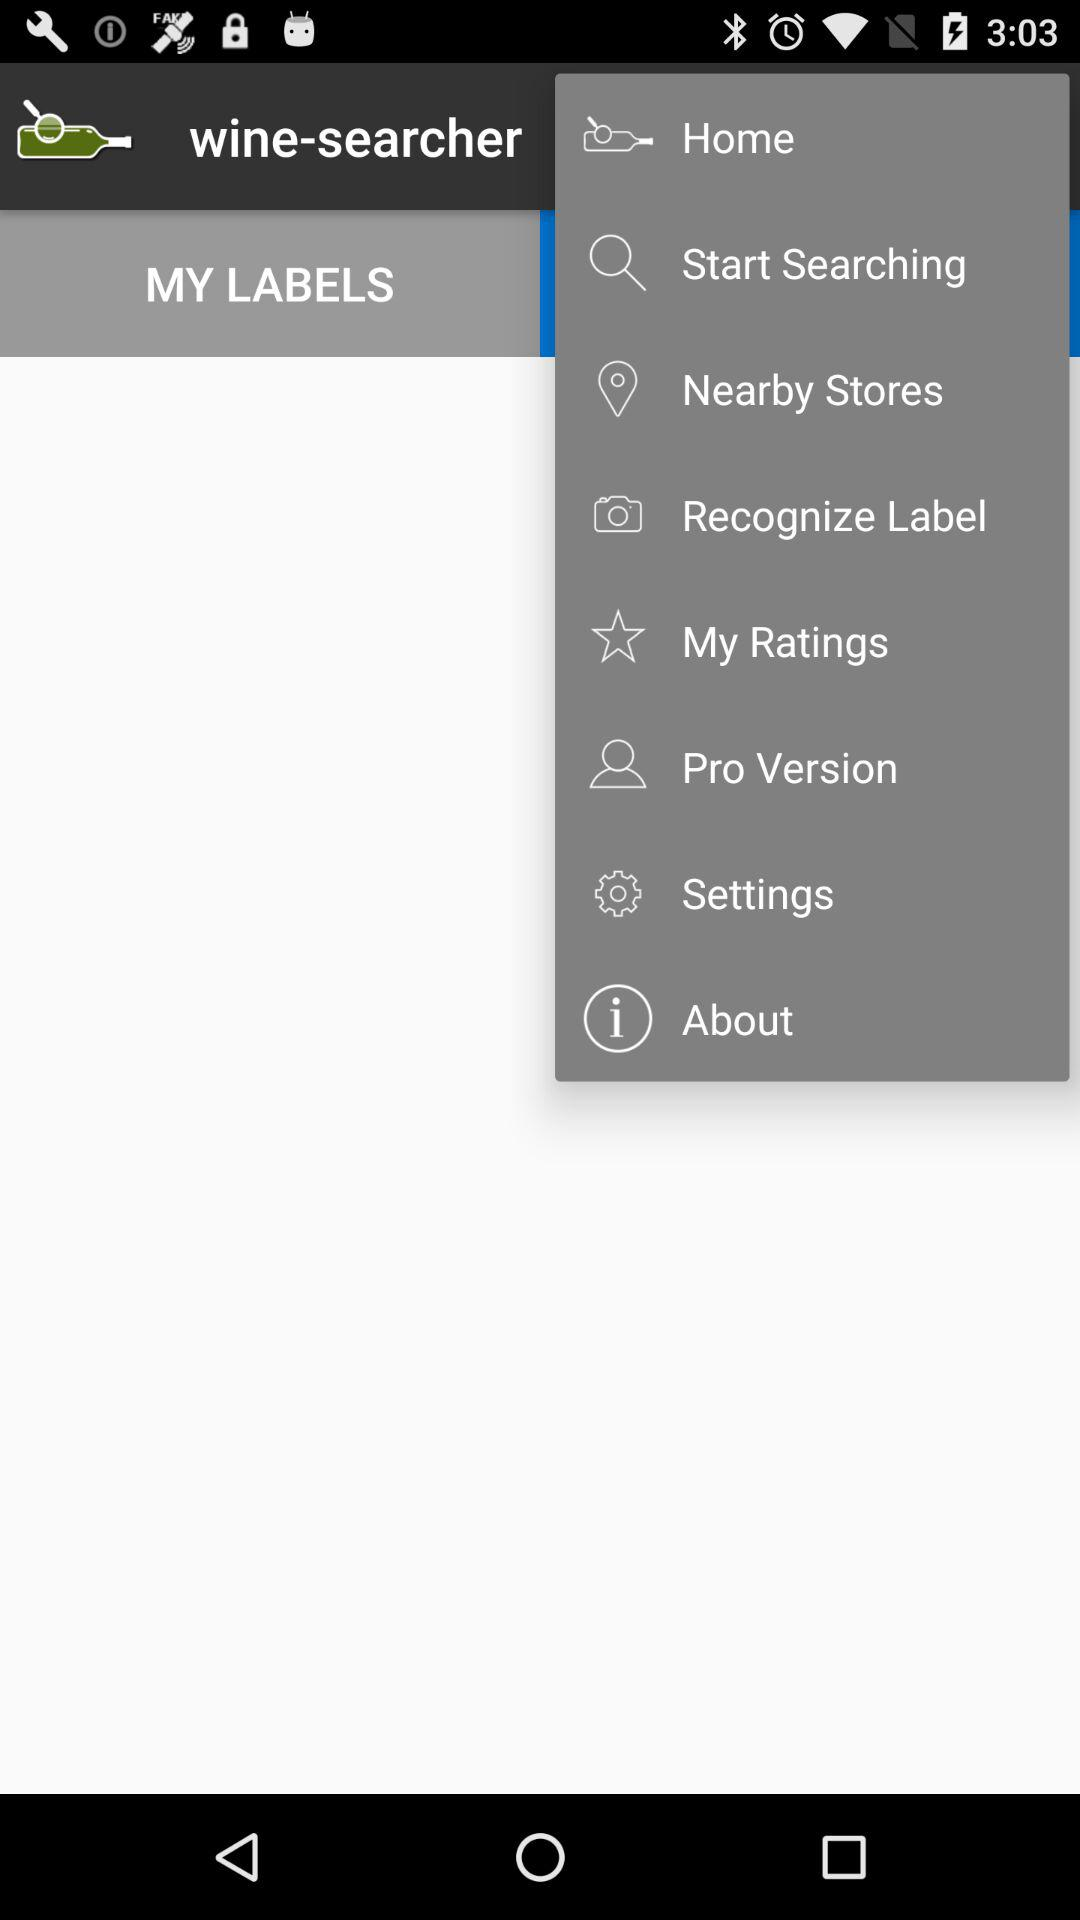What is the name of the application? The name of the application is "wine-searcher". 